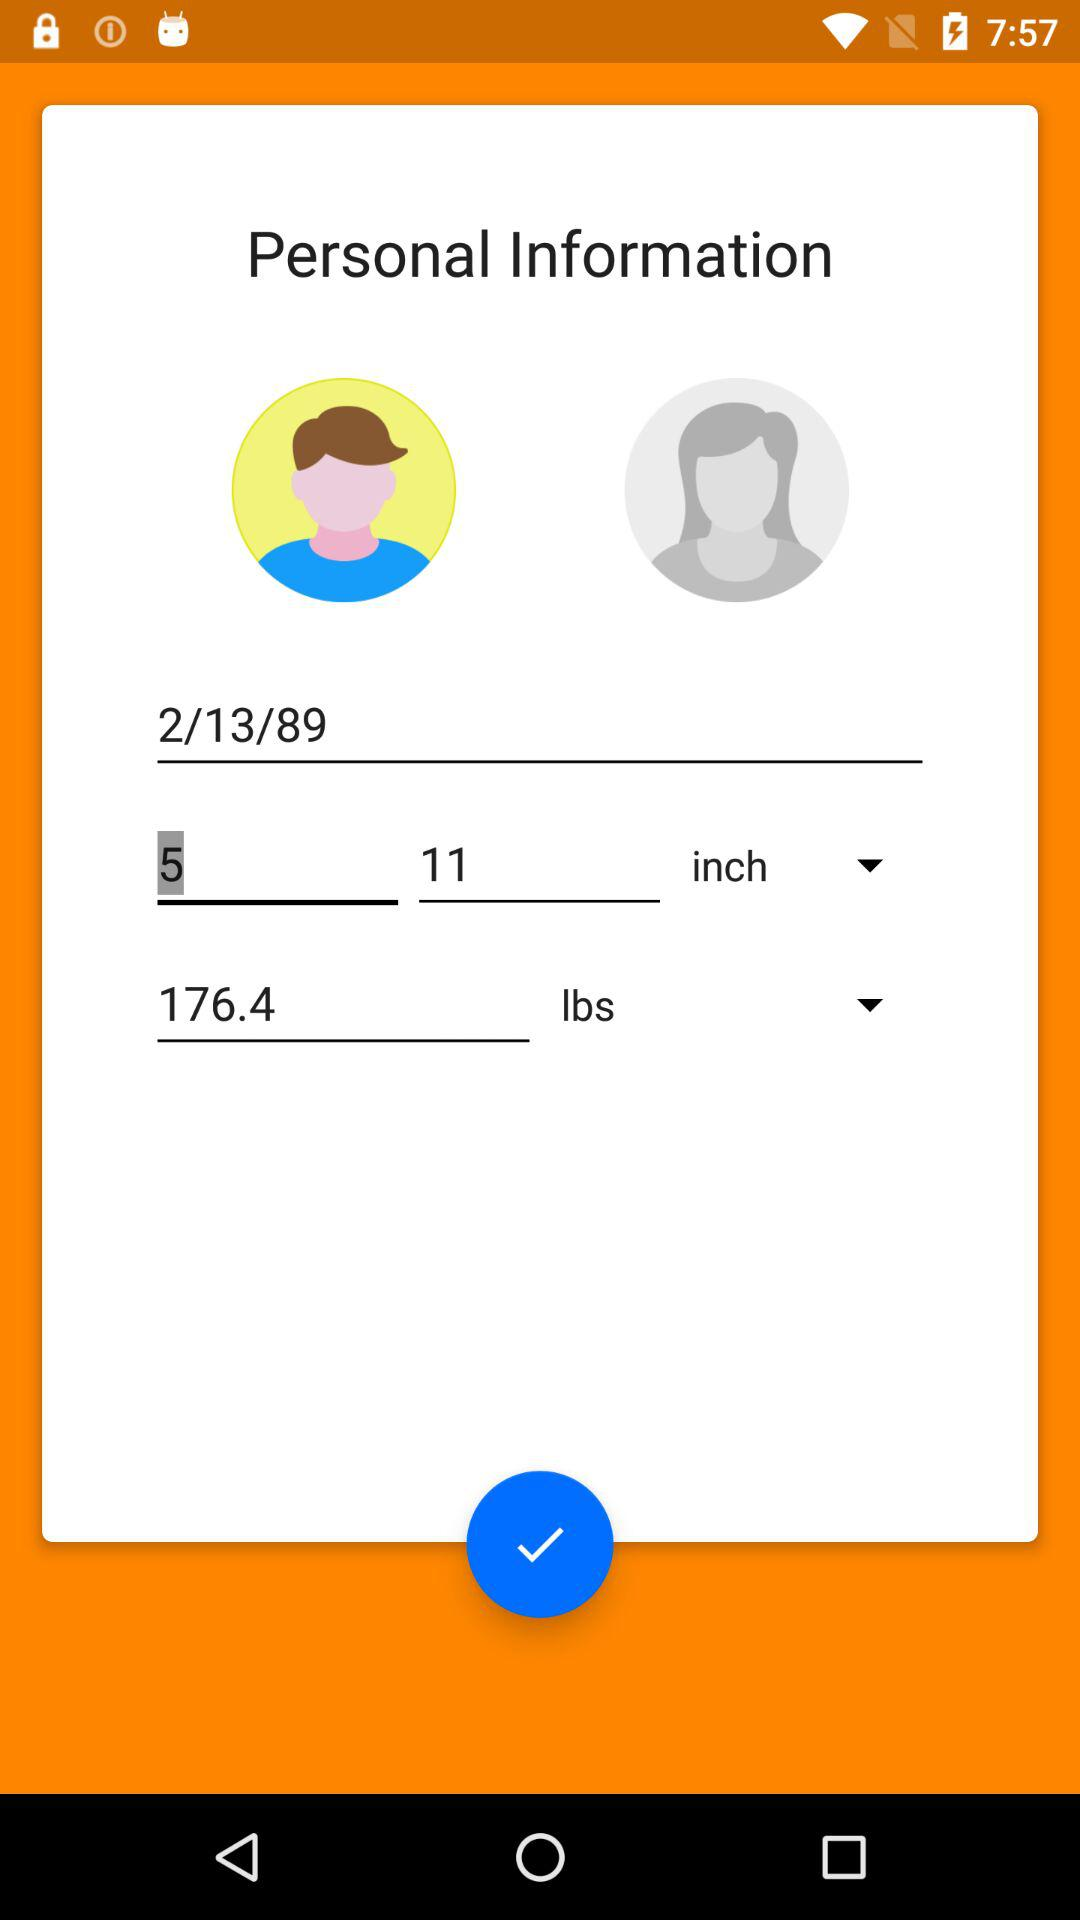What is the height? The height is 5 feet 11 inches. 